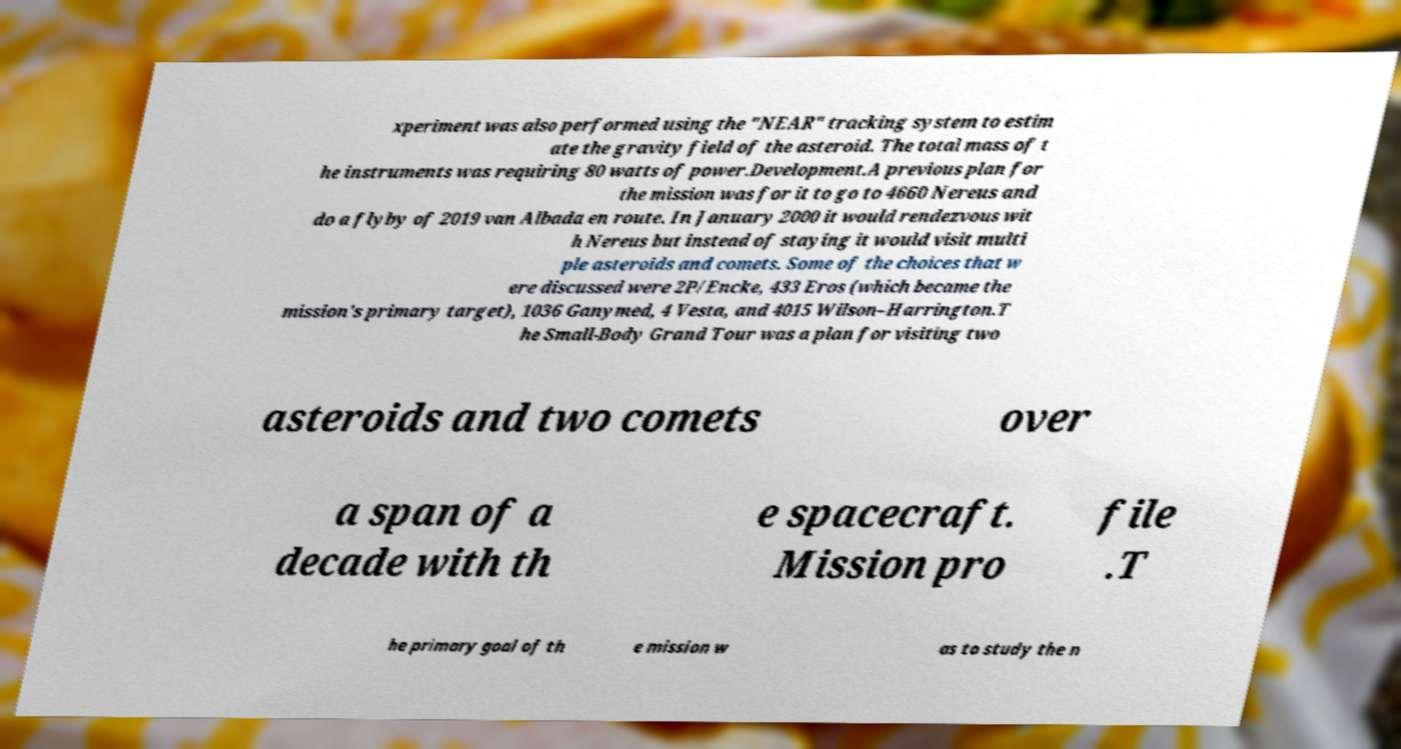Can you accurately transcribe the text from the provided image for me? xperiment was also performed using the "NEAR" tracking system to estim ate the gravity field of the asteroid. The total mass of t he instruments was requiring 80 watts of power.Development.A previous plan for the mission was for it to go to 4660 Nereus and do a flyby of 2019 van Albada en route. In January 2000 it would rendezvous wit h Nereus but instead of staying it would visit multi ple asteroids and comets. Some of the choices that w ere discussed were 2P/Encke, 433 Eros (which became the mission's primary target), 1036 Ganymed, 4 Vesta, and 4015 Wilson–Harrington.T he Small-Body Grand Tour was a plan for visiting two asteroids and two comets over a span of a decade with th e spacecraft. Mission pro file .T he primary goal of th e mission w as to study the n 